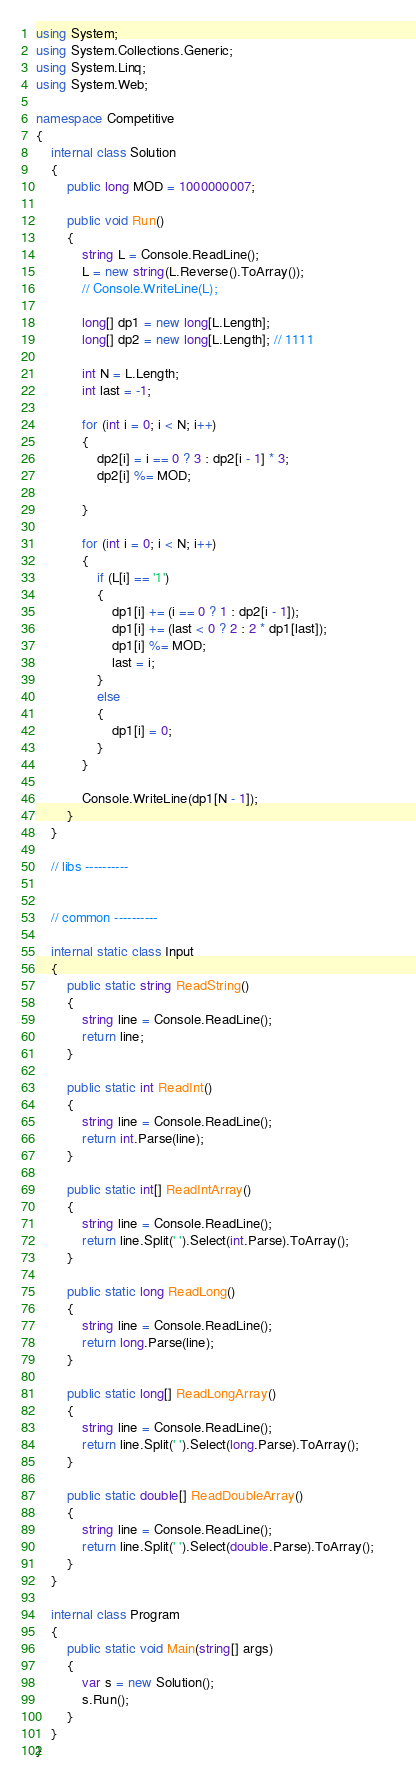Convert code to text. <code><loc_0><loc_0><loc_500><loc_500><_C#_>using System;
using System.Collections.Generic;
using System.Linq;
using System.Web;

namespace Competitive
{
    internal class Solution
    {
        public long MOD = 1000000007;

        public void Run()
        {
            string L = Console.ReadLine();
            L = new string(L.Reverse().ToArray());
            // Console.WriteLine(L);

            long[] dp1 = new long[L.Length];
            long[] dp2 = new long[L.Length]; // 1111

            int N = L.Length;
            int last = -1;

            for (int i = 0; i < N; i++)
            {
                dp2[i] = i == 0 ? 3 : dp2[i - 1] * 3;
                dp2[i] %= MOD;

            }

            for (int i = 0; i < N; i++)
            {
                if (L[i] == '1')
                {
                    dp1[i] += (i == 0 ? 1 : dp2[i - 1]);
                    dp1[i] += (last < 0 ? 2 : 2 * dp1[last]);
                    dp1[i] %= MOD;
                    last = i;
                }
                else
                {
                    dp1[i] = 0;
                }
            }

            Console.WriteLine(dp1[N - 1]);
        }
    }

    // libs ----------
    

    // common ----------

    internal static class Input
    {
        public static string ReadString()
        {
            string line = Console.ReadLine();
            return line;
        }

        public static int ReadInt()
        {
            string line = Console.ReadLine();
            return int.Parse(line);
        }

        public static int[] ReadIntArray()
        {
            string line = Console.ReadLine();
            return line.Split(' ').Select(int.Parse).ToArray();            
        }

        public static long ReadLong()
        {
            string line = Console.ReadLine();
            return long.Parse(line);
        }

        public static long[] ReadLongArray()
        {
            string line = Console.ReadLine();
            return line.Split(' ').Select(long.Parse).ToArray();
        }

        public static double[] ReadDoubleArray()
        {
            string line = Console.ReadLine();
            return line.Split(' ').Select(double.Parse).ToArray();
        }
    }
    
    internal class Program
    {
        public static void Main(string[] args)
        {
            var s = new Solution();
            s.Run();
        }
    }
}</code> 